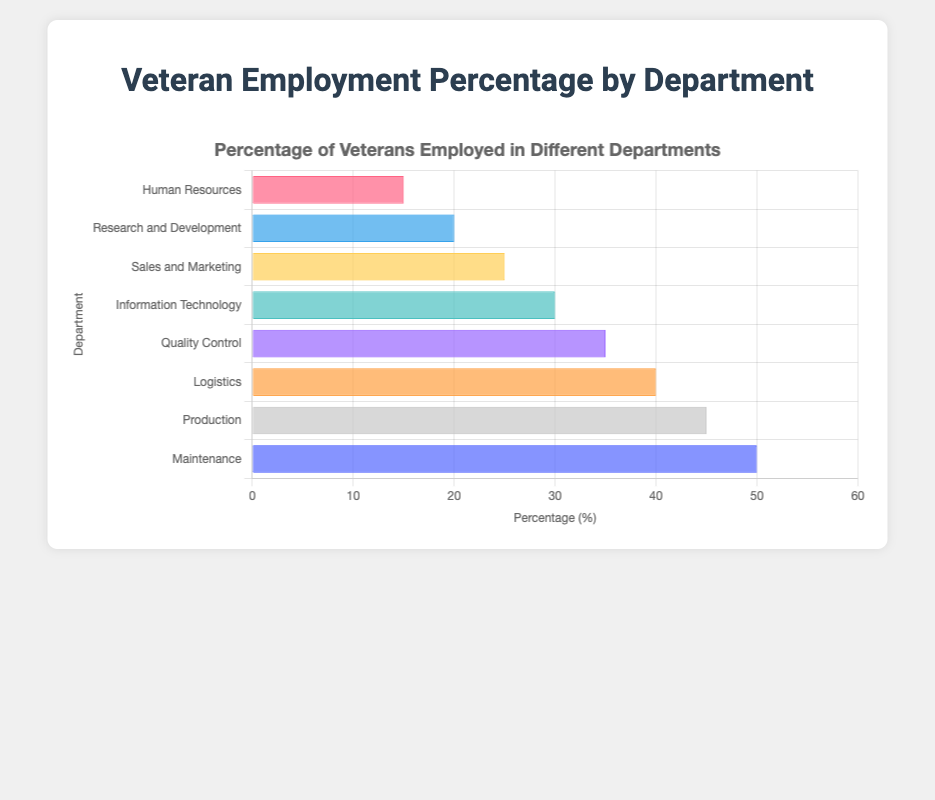Which department has the highest percentage of veterans employed? Check which bar is the longest or has the highest value on the horizontal axis. The 'Maintenance' department has the highest value at 50%.
Answer: Maintenance Which department employs fewer veterans, Sales and Marketing or Research and Development? Compare the lengths of the bars or the values for each department. Sales and Marketing has 25%, while Research and Development has 20%. Therefore, Research and Development employs fewer veterans.
Answer: Research and Development What is the total percentage of veterans employed in Production and Logistics departments combined? Add the percentages of veterans employed in Production and Logistics. Production has 45% and Logistics has 40%. Sum: 45 + 40 = 85%.
Answer: 85% Is the percentage of veterans employed in Information Technology higher than in Quality Control? Compare the values for Information Technology and Quality Control. Information Technology has 30%, while Quality Control has 35%. Hence, the percentage is higher in Quality Control.
Answer: No What is the difference in veteran employment percentage between Maintenance and Human Resources? Subtract the percentage of Human Resources from that of Maintenance. Maintenance has 50% and Human Resources has 15%. Difference: 50 - 15 = 35%.
Answer: 35% Which departments employ exactly 30% or more veterans? Check which bars reach at least the 30% mark on the horizontal axis. The departments are Information Technology (30%), Quality Control (35%), Logistics (40%), Production (45%), and Maintenance (50%).
Answer: Information Technology, Quality Control, Logistics, Production, Maintenance Which department has a bar colored green, and what percentage of veterans does it employ? Identify the bar colored green. In this case, Information Technology's bar is green and has a percentage of 30%.
Answer: Information Technology, 30% Rank the departments with the highest to lowest percentage of veterans employed. Organize the departments by their veteran employment percentages in descending order. Rank: Maintenance (50%), Production (45%), Logistics (40%), Quality Control (35%), Information Technology (30%), Sales and Marketing (25%), Research and Development (20%), Human Resources (15%).
Answer: Maintenance, Production, Logistics, Quality Control, Information Technology, Sales and Marketing, Research and Development, Human Resources What is the average percentage of veterans employed across all departments? Add all the percentages and divide by the number of departments. Percentages: 45 + 35 + 50 + 40 + 20 + 25 + 15 + 30 = 260. Number of departments: 8. Average: 260 / 8 = 32.5%.
Answer: 32.5% Is the veteran employment percentage in the Sales and Marketing department more than double that in Human Resources? Check the percentages and compare. Sales and Marketing has 25%, and double Human Resources (15%) is 15 x 2 = 30%. Since 25% is less than 30%, the answer is no.
Answer: No 